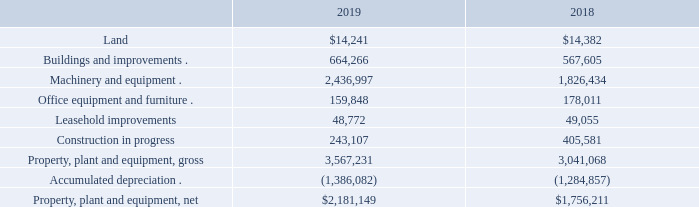Property, plant and equipment, net
Property, plant and equipment, net consisted of the following at December 31, 2019 and 2018 (in thousands):
We periodically assess the estimated useful lives of our property, plant and equipment whenever applicable facts and circumstances indicate a change in the estimated useful life of an asset may have occurred. During the year ended December 31, 2019, we revised the estimated useful lives of certain core Series 6 manufacturing equipment from 10 years to 15 years. Such revision was primarily due to the validation of certain aspects of our Series 6 module technology, including the nature of the manufacturing process, the operating and maintenance cost profile of the manufacturing equipment, and the technology’s compatibility with our long-term module technology roadmap. We expect the revised useful lives to reduce depreciation by approximately $15.0 million per year. Depreciation of property, plant and equipment was $176.4 million, $109.1 million, and $91.4 million for the years ended December 31, 2019, 2018, and 2017, respectively.
What were the reasons for the revision of manufacturing equipment in 2019? Such revision was primarily due to the validation of certain aspects of our series 6 module technology, including the nature of the manufacturing process, the operating and maintenance cost profile of the manufacturing equipment, and the technology’s compatibility with our long-term module technology roadmap. How much will depreciation expense decrease as a result of the revision in useful life? Reduce depreciation by approximately $15.0 million per year. What was the depreciation of property, plant and equipment in 2019?  $176.4 million. What was the increase in machinery and equipment from 2018 to 2019?
Answer scale should be: thousand. 2,436,997 - 1,826,434 
Answer: 610563. What is the difference between land from 2018 to 2019?
Answer scale should be: thousand. 14,241 - 14,382 
Answer: -141. What is the percentage increase in net property, plant and equipment from 2018 to 2019?
Answer scale should be: percent. (2,181,149 - 1,756,211)/1,756,211 
Answer: 24.2. 